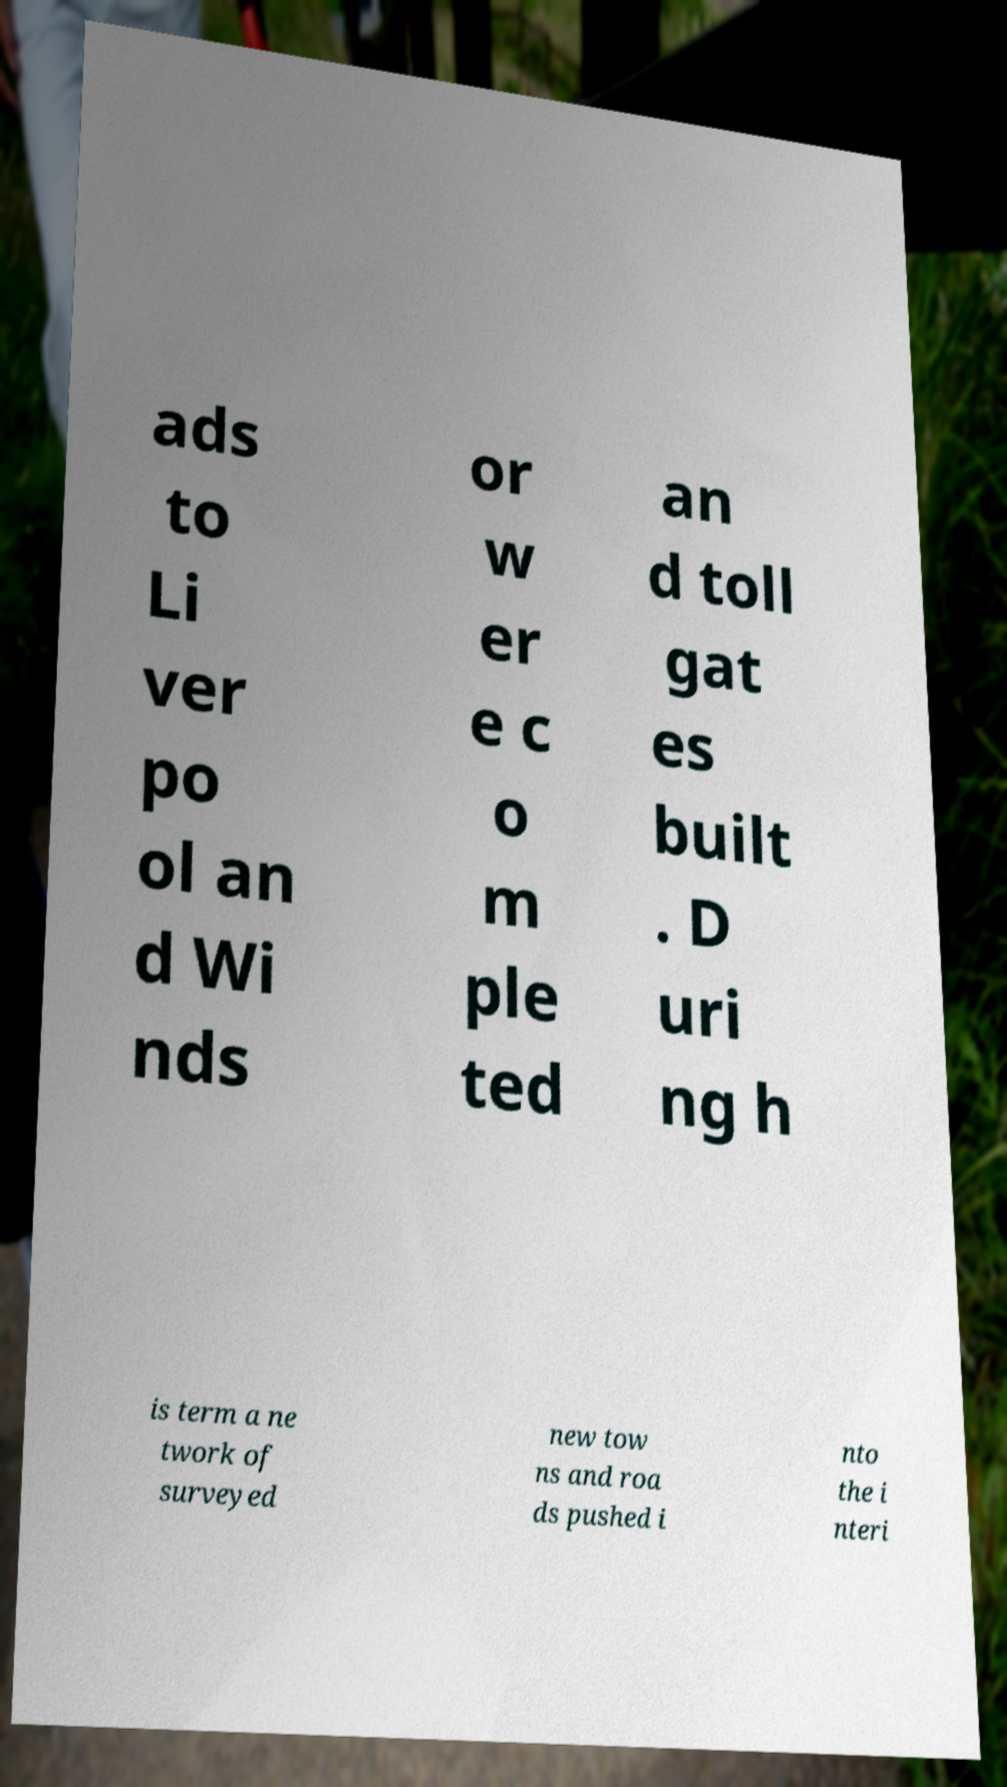Can you read and provide the text displayed in the image?This photo seems to have some interesting text. Can you extract and type it out for me? ads to Li ver po ol an d Wi nds or w er e c o m ple ted an d toll gat es built . D uri ng h is term a ne twork of surveyed new tow ns and roa ds pushed i nto the i nteri 